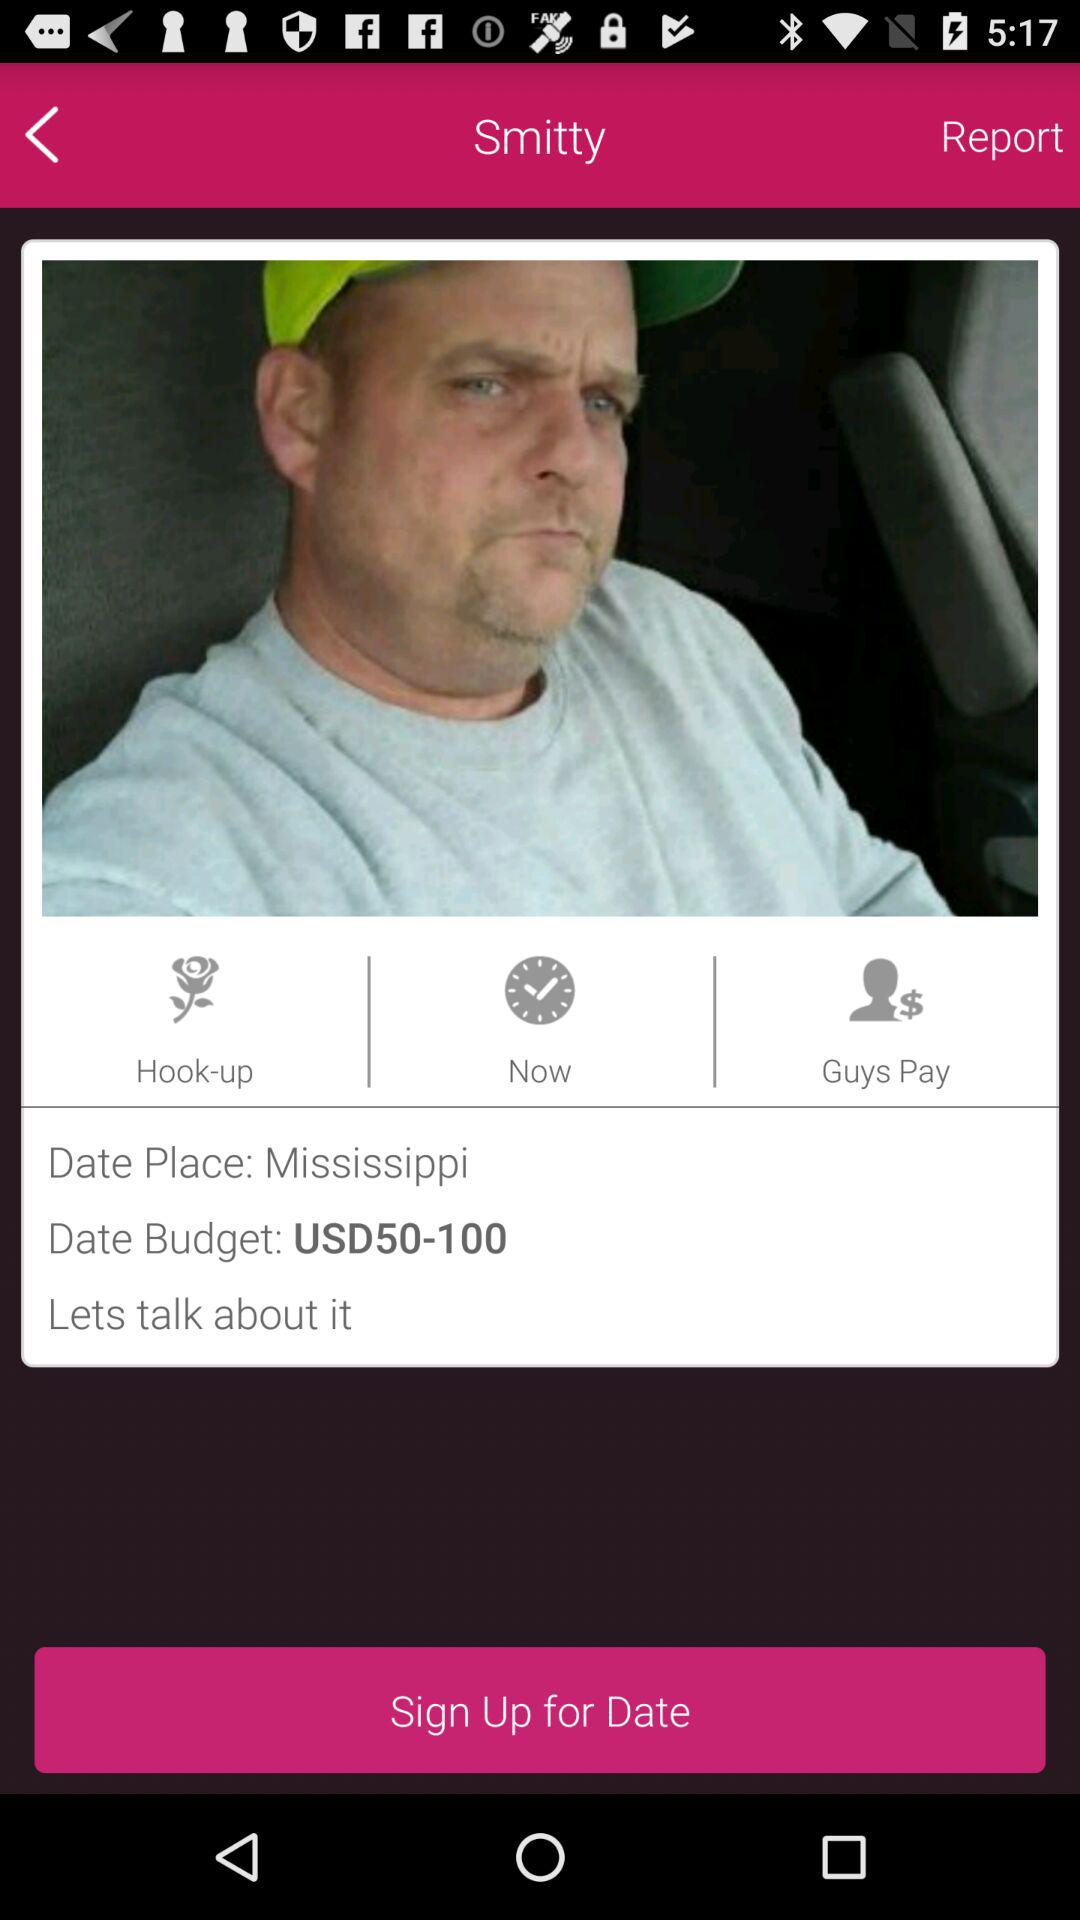What is the place of the date? The place of the date is Mississippi. 